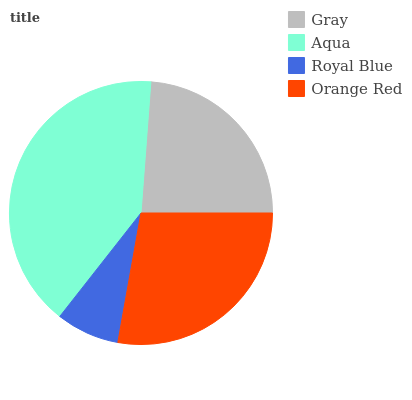Is Royal Blue the minimum?
Answer yes or no. Yes. Is Aqua the maximum?
Answer yes or no. Yes. Is Aqua the minimum?
Answer yes or no. No. Is Royal Blue the maximum?
Answer yes or no. No. Is Aqua greater than Royal Blue?
Answer yes or no. Yes. Is Royal Blue less than Aqua?
Answer yes or no. Yes. Is Royal Blue greater than Aqua?
Answer yes or no. No. Is Aqua less than Royal Blue?
Answer yes or no. No. Is Orange Red the high median?
Answer yes or no. Yes. Is Gray the low median?
Answer yes or no. Yes. Is Royal Blue the high median?
Answer yes or no. No. Is Orange Red the low median?
Answer yes or no. No. 